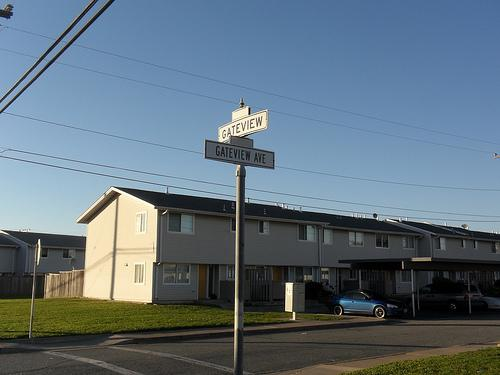In a few sentences, provide a general description of the scene. The scene takes place in a suburban area, with houses on the side of the road, a blue car parked near a curb, and various street signs. There is green grass, a wooden fence, and a clear blue sky. Describe the condition of the fence and the grass in the image. The fence is old and wooden, while the grass appears healthy and green. How many windows can be seen in the entire image, and what do they belong to? There are about 12 windows, belonging to the houses on the side of the road. What type of environment is shown in the image, and can you identify any nature-related objects? The environment is a suburban neighborhood, with houses, grass lawns, and a clear blue sky. Identify a prominent sign in the image and its content. There is a prominent street sign that says "Gateway Ave." Identify two different types of lines in the image and where they appear. There are white street lines on the road and white crosswalk stripes on the street. List two objects found in the image along with their colors and sizes. A small blue car is parked in the driveway, and there is a big brown van nearby. Choose any building in the image and provide a brief description of its appearance. A very nice big house with several windows, a tan siding, a black roof, and a yellow door can be seen. What type of vehicle is parked in the driveway and what color is it? A blue car is parked in the driveway. Mention a few items found on the front lawn of a house in the image. Items found on the front lawn include green grass, a mailbox, and a wooden fence. Can you spot a charming white picket fence? The image contains a wooden fence, but it's described as old and not white. This instruction inaccurately portrays the fence using different and contradictory characteristics. Can you find a rusty old swing set in the yard? There is no mention of a swing set or any play equipment in the yard. This instruction adds a completely new object with particular attributes (rusty old). Describe the lush, verdant trees around the house. While there is grass mentioned in the image, there are no trees described. This instruction inaccurately adds a new element (trees) with specific characteristics (lush, verdant). Does the street sign say "Elm Street"? The street sign in the image says "Gateway Ave," not "Elm Street." This instruction attempts to change the content of the sign with false information. Are there any cats or dogs playing on the grass? There is no mention of any animals, specifically cats or dogs, in the image. This misleading instruction introduces non-existing elements into the scene. Are there any bicycles parked near the buildings? No, it's not mentioned in the image. Is the house painted in a vibrant pink color? The house is described as a very nice big house, but there is no mention of its color. Adding a specific color like vibrant pink creates a misleading instruction. Is there a large red firetruck in the image? There is no mention of a firetruck in the image, let alone a large red one. This misleading instruction adds a nonexistent object with a specific color and size. 